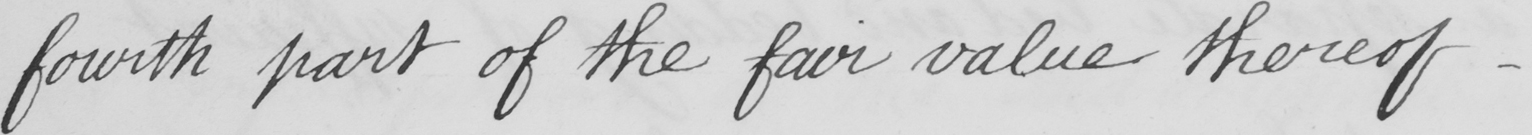What does this handwritten line say? fourth part of the fair value thereof  _ 